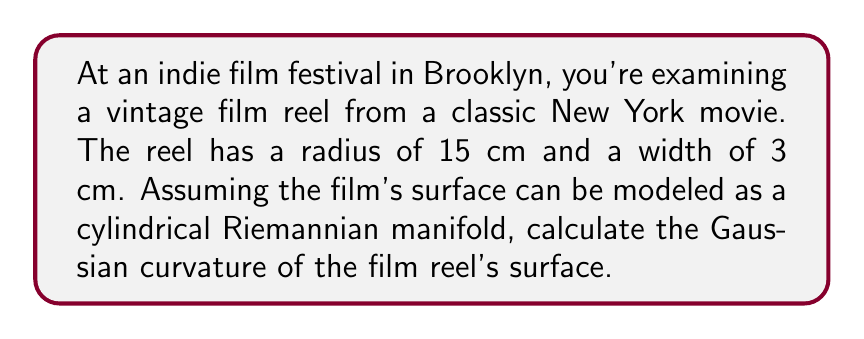Give your solution to this math problem. To solve this problem, we'll follow these steps:

1. Understand the geometry of the film reel:
   The surface of the film reel can be modeled as a cylinder, which is a type of Riemannian manifold.

2. Recall the formula for Gaussian curvature of a cylinder:
   For a cylinder with radius $r$, the Gaussian curvature $K$ is given by:

   $$K = \frac{1}{r_1 r_2}$$

   where $r_1$ is the radius of the cylinder and $r_2$ is the radius of curvature in the orthogonal direction.

3. Identify the radii of curvature:
   - $r_1 = 15$ cm (given radius of the reel)
   - $r_2 = \infty$ (the cylinder is flat in the direction parallel to its axis)

4. Calculate the Gaussian curvature:
   $$K = \frac{1}{r_1 r_2} = \frac{1}{15 \cdot \infty} = 0$$

The Gaussian curvature of a cylinder is zero because it is flat in one direction (along its length) and curved in the other (around its circumference).

This result is consistent with the fact that a cylinder is a developable surface, meaning it can be flattened onto a plane without distortion. All developable surfaces have zero Gaussian curvature at every point.

[asy]
import geometry;

size(200);
real r = 3;
real h = 2;

path3 p = (r,0,0)..(0,r,0)..(-r,0,0)..(0,-r,0)..cycle;
revolution s = revolution(p, Z);
draw(surface(s), lightgray);
draw(s, blue);

draw((0,0,-h/2)--(0,0,h/2), dashed);
label("r", (r/2,r/2,0), NE);
[/asy]
Answer: The Gaussian curvature of the film reel's surface is $K = 0$. 